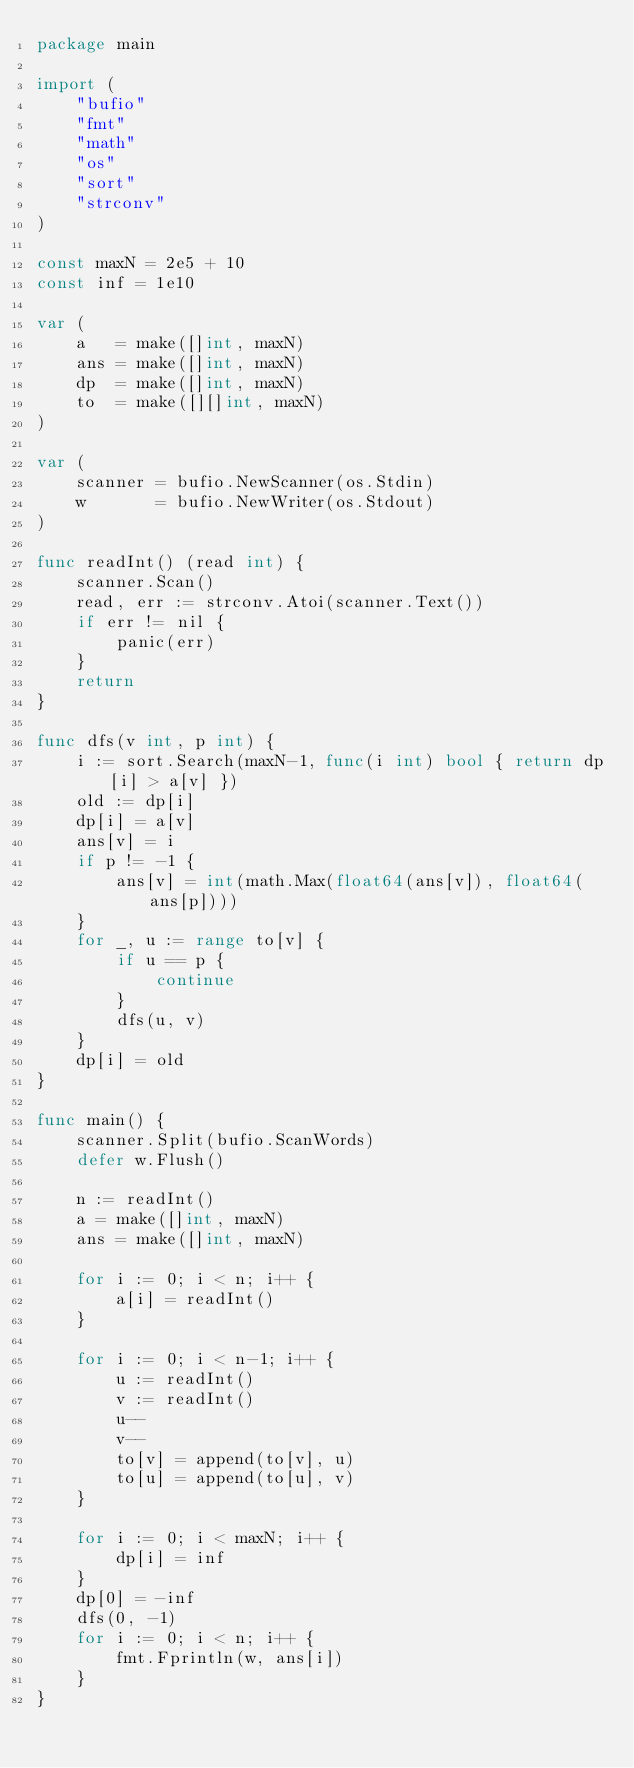Convert code to text. <code><loc_0><loc_0><loc_500><loc_500><_Go_>package main

import (
	"bufio"
	"fmt"
	"math"
	"os"
	"sort"
	"strconv"
)

const maxN = 2e5 + 10
const inf = 1e10

var (
	a   = make([]int, maxN)
	ans = make([]int, maxN)
	dp  = make([]int, maxN)
	to  = make([][]int, maxN)
)

var (
	scanner = bufio.NewScanner(os.Stdin)
	w       = bufio.NewWriter(os.Stdout)
)

func readInt() (read int) {
	scanner.Scan()
	read, err := strconv.Atoi(scanner.Text())
	if err != nil {
		panic(err)
	}
	return
}

func dfs(v int, p int) {
	i := sort.Search(maxN-1, func(i int) bool { return dp[i] > a[v] })
	old := dp[i]
	dp[i] = a[v]
	ans[v] = i
	if p != -1 {
		ans[v] = int(math.Max(float64(ans[v]), float64(ans[p])))
	}
	for _, u := range to[v] {
		if u == p {
			continue
		}
		dfs(u, v)
	}
	dp[i] = old
}

func main() {
	scanner.Split(bufio.ScanWords)
	defer w.Flush()

	n := readInt()
	a = make([]int, maxN)
	ans = make([]int, maxN)

	for i := 0; i < n; i++ {
		a[i] = readInt()
	}

	for i := 0; i < n-1; i++ {
		u := readInt()
		v := readInt()
		u--
		v--
		to[v] = append(to[v], u)
		to[u] = append(to[u], v)
	}

	for i := 0; i < maxN; i++ {
		dp[i] = inf
	}
	dp[0] = -inf
	dfs(0, -1)
	for i := 0; i < n; i++ {
		fmt.Fprintln(w, ans[i])
	}
}
</code> 